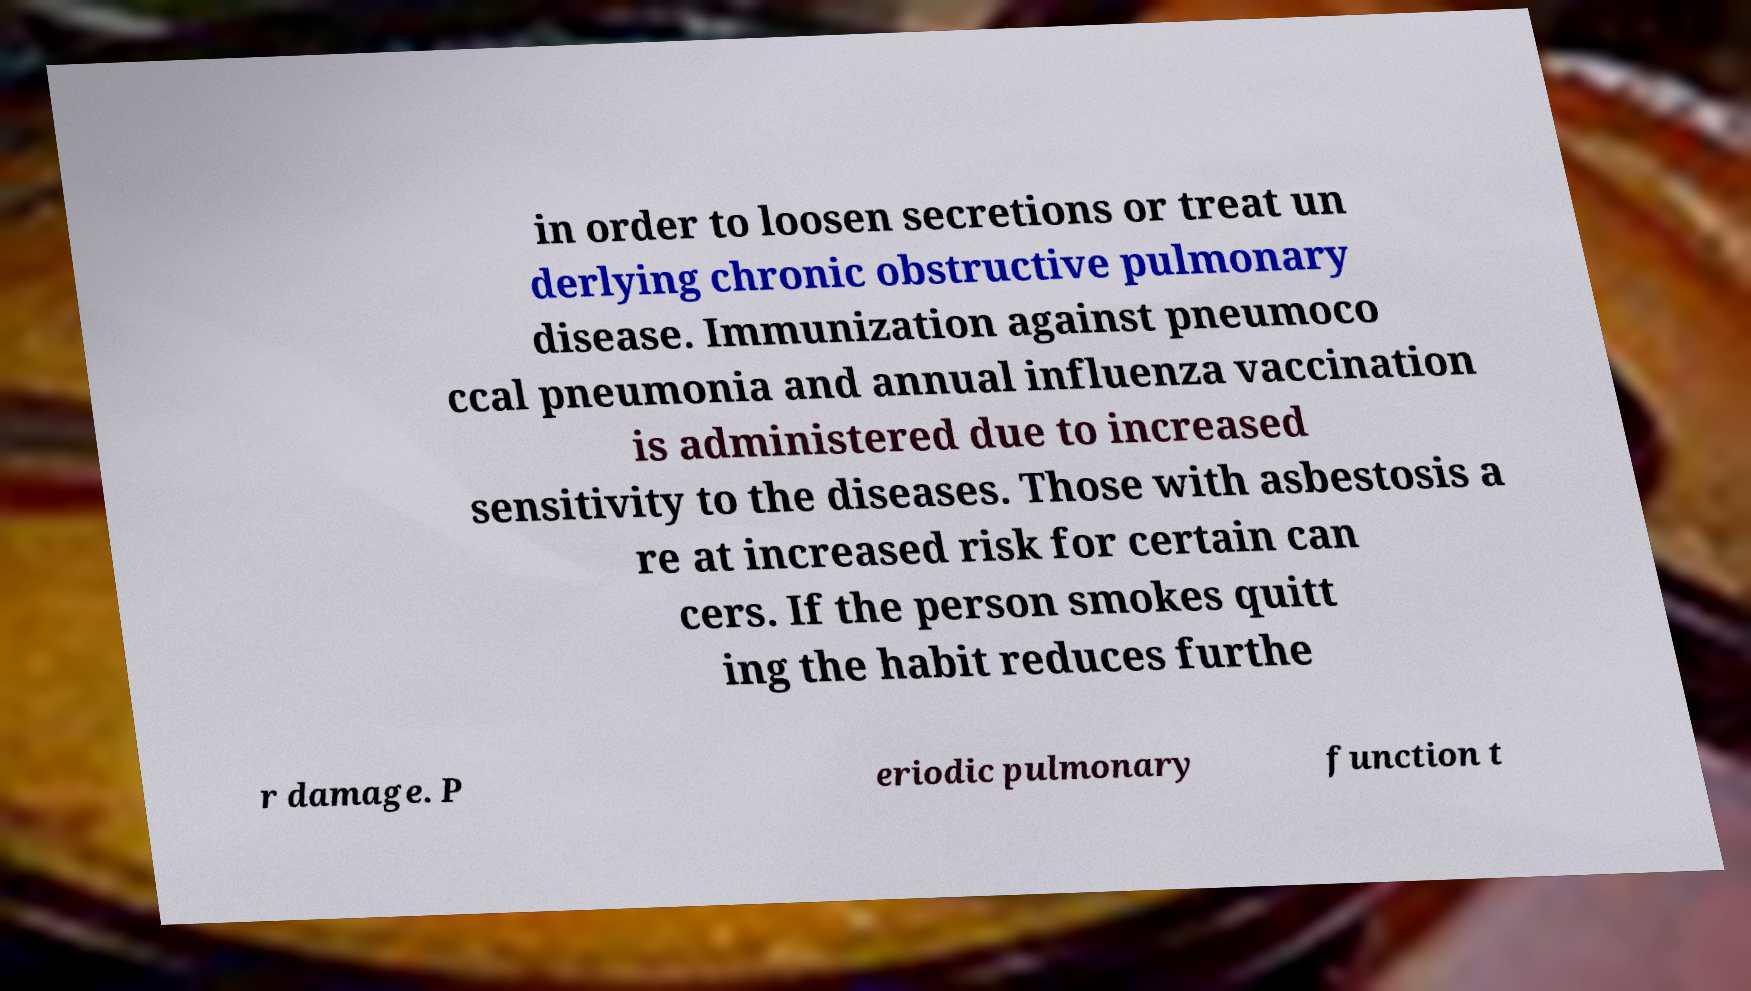I need the written content from this picture converted into text. Can you do that? in order to loosen secretions or treat un derlying chronic obstructive pulmonary disease. Immunization against pneumoco ccal pneumonia and annual influenza vaccination is administered due to increased sensitivity to the diseases. Those with asbestosis a re at increased risk for certain can cers. If the person smokes quitt ing the habit reduces furthe r damage. P eriodic pulmonary function t 